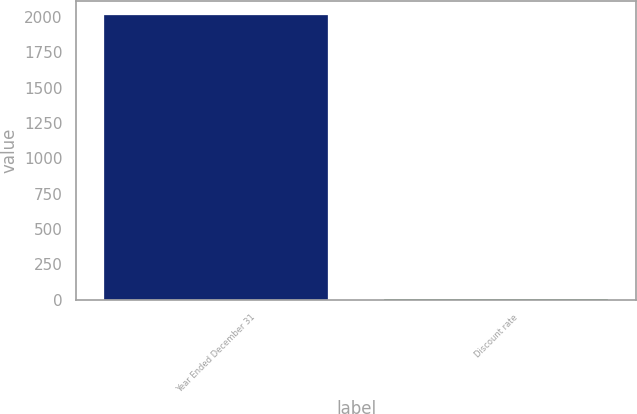Convert chart to OTSL. <chart><loc_0><loc_0><loc_500><loc_500><bar_chart><fcel>Year Ended December 31<fcel>Discount rate<nl><fcel>2011<fcel>5.3<nl></chart> 